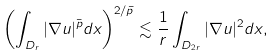<formula> <loc_0><loc_0><loc_500><loc_500>\left ( \int _ { D _ { r } } | \nabla u | ^ { \bar { p } } d x \right ) ^ { 2 / \bar { p } } \lesssim \frac { 1 } { r } \int _ { D _ { 2 r } } | \nabla u | ^ { 2 } d x ,</formula> 